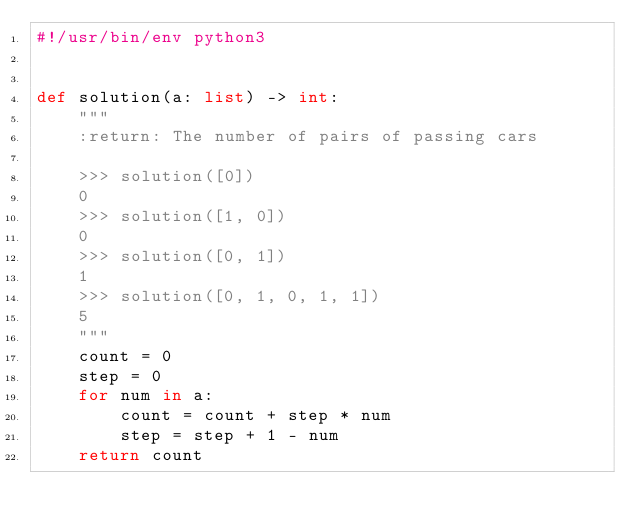Convert code to text. <code><loc_0><loc_0><loc_500><loc_500><_Python_>#!/usr/bin/env python3


def solution(a: list) -> int:
    """
    :return: The number of pairs of passing cars

    >>> solution([0])
    0
    >>> solution([1, 0])
    0
    >>> solution([0, 1])
    1
    >>> solution([0, 1, 0, 1, 1])
    5
    """
    count = 0
    step = 0
    for num in a:
        count = count + step * num
        step = step + 1 - num
    return count
</code> 